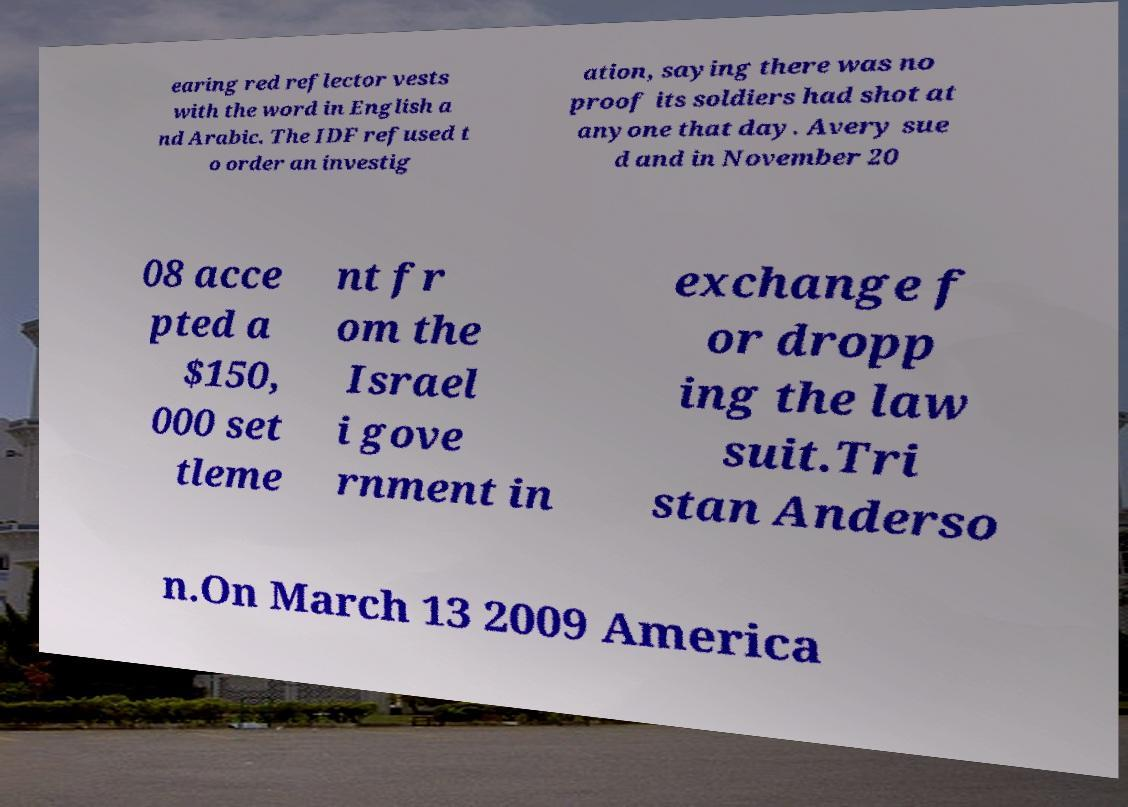Please identify and transcribe the text found in this image. earing red reflector vests with the word in English a nd Arabic. The IDF refused t o order an investig ation, saying there was no proof its soldiers had shot at anyone that day. Avery sue d and in November 20 08 acce pted a $150, 000 set tleme nt fr om the Israel i gove rnment in exchange f or dropp ing the law suit.Tri stan Anderso n.On March 13 2009 America 